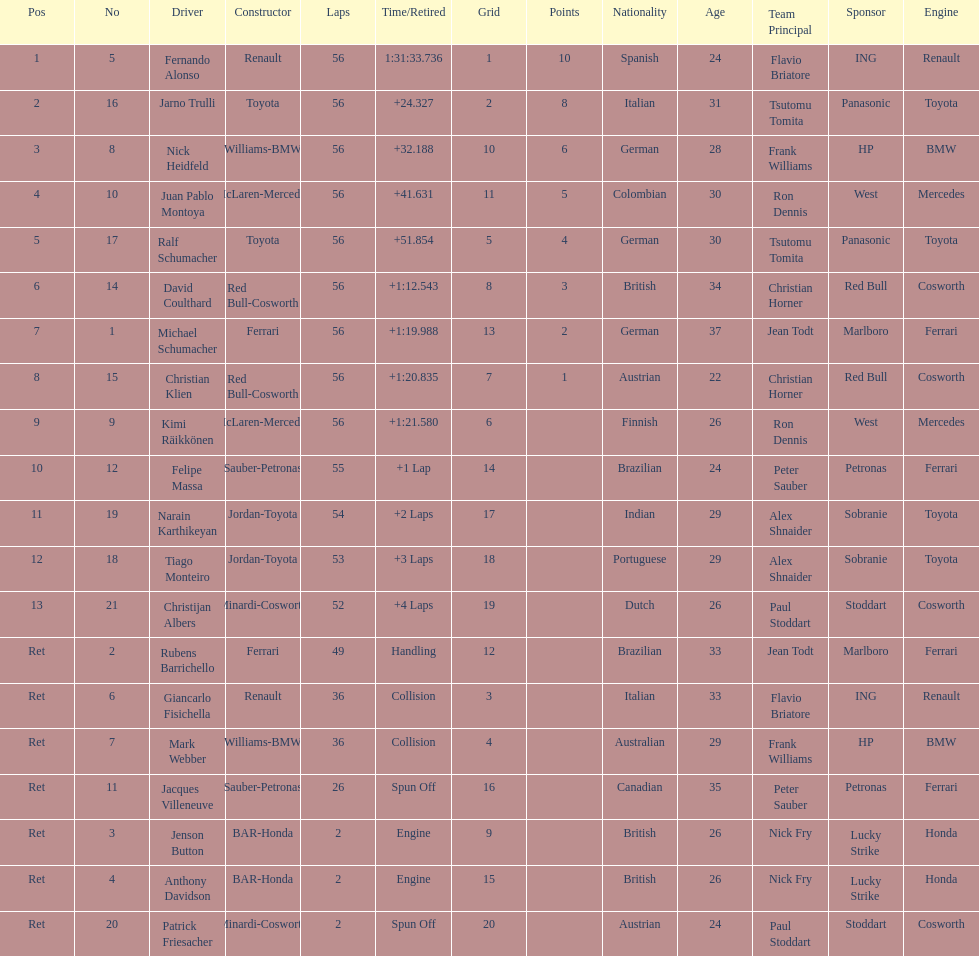What driver finished first? Fernando Alonso. 